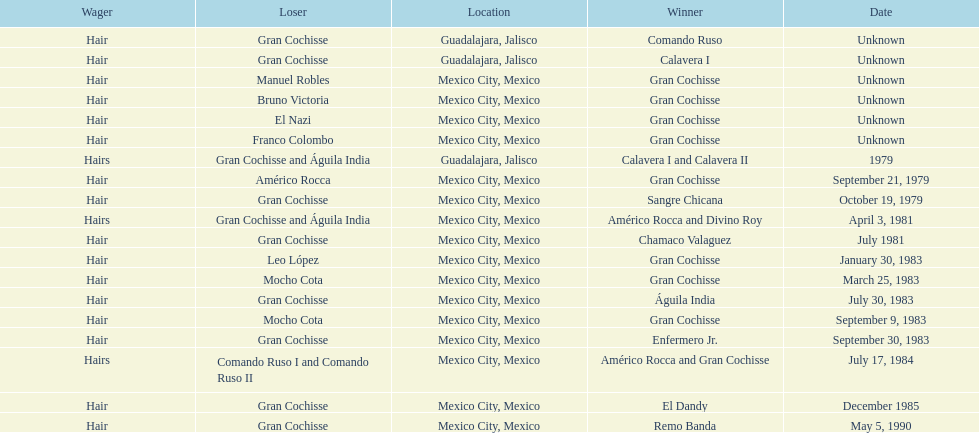How many times has the wager been hair? 16. 